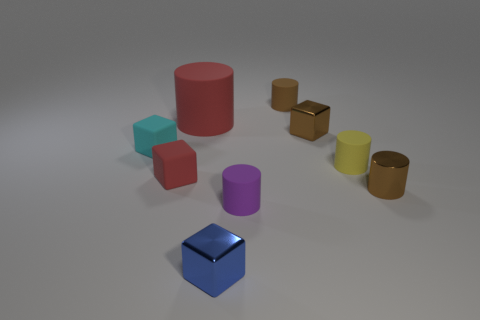There is another shiny thing that is the same shape as the tiny blue shiny object; what color is it?
Offer a very short reply. Brown. What number of rubber objects are behind the brown cylinder behind the small brown metallic thing in front of the small yellow object?
Provide a succinct answer. 0. Is the number of red matte cylinders that are in front of the red matte cylinder less than the number of red rubber cylinders?
Your response must be concise. Yes. There is another shiny object that is the same shape as the tiny blue metallic thing; what is its size?
Your answer should be very brief. Small. What number of small yellow objects are the same material as the purple thing?
Make the answer very short. 1. Is the material of the object behind the red cylinder the same as the small blue thing?
Your answer should be compact. No. Are there the same number of blue metal blocks behind the tiny purple rubber cylinder and big yellow matte blocks?
Your answer should be very brief. Yes. What is the size of the red matte cylinder?
Offer a very short reply. Large. There is a block that is the same color as the large rubber cylinder; what is it made of?
Your answer should be compact. Rubber. How many other shiny cylinders are the same color as the metallic cylinder?
Your response must be concise. 0. 